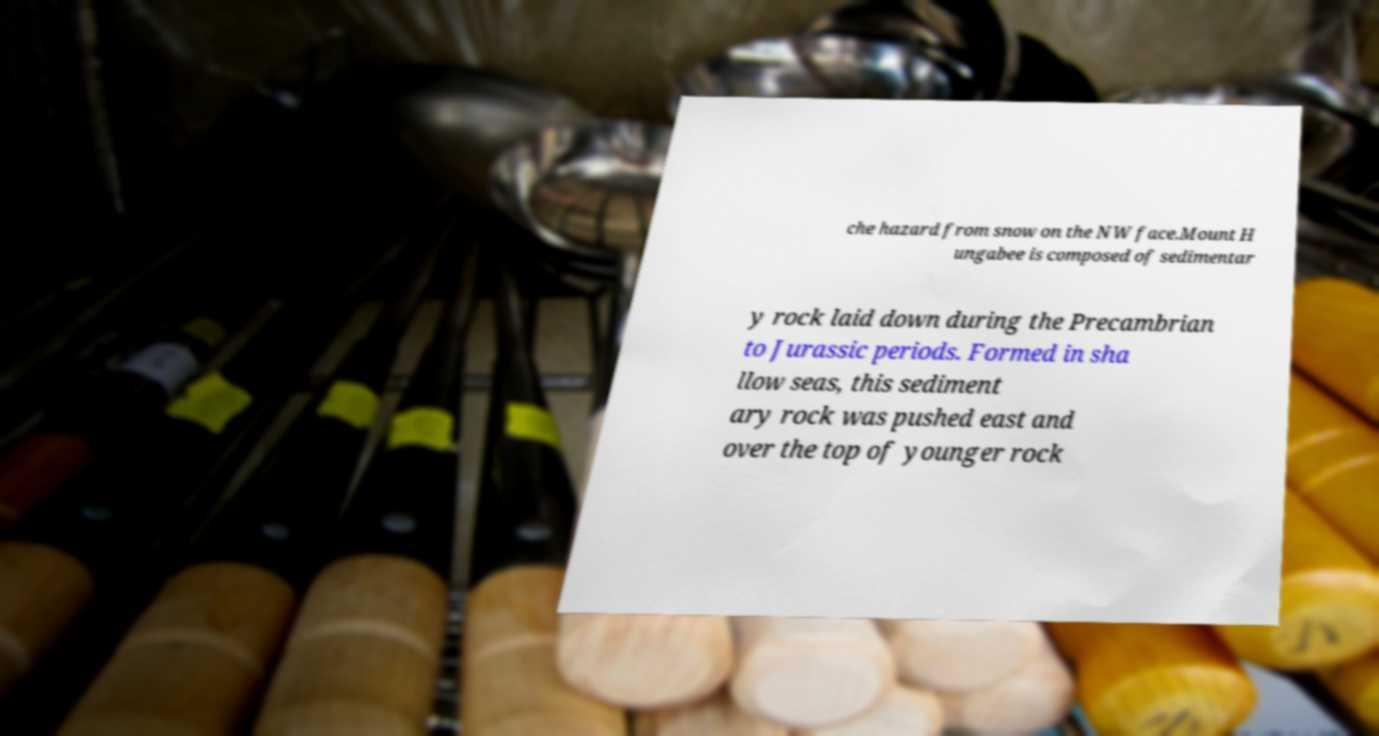Please identify and transcribe the text found in this image. che hazard from snow on the NW face.Mount H ungabee is composed of sedimentar y rock laid down during the Precambrian to Jurassic periods. Formed in sha llow seas, this sediment ary rock was pushed east and over the top of younger rock 